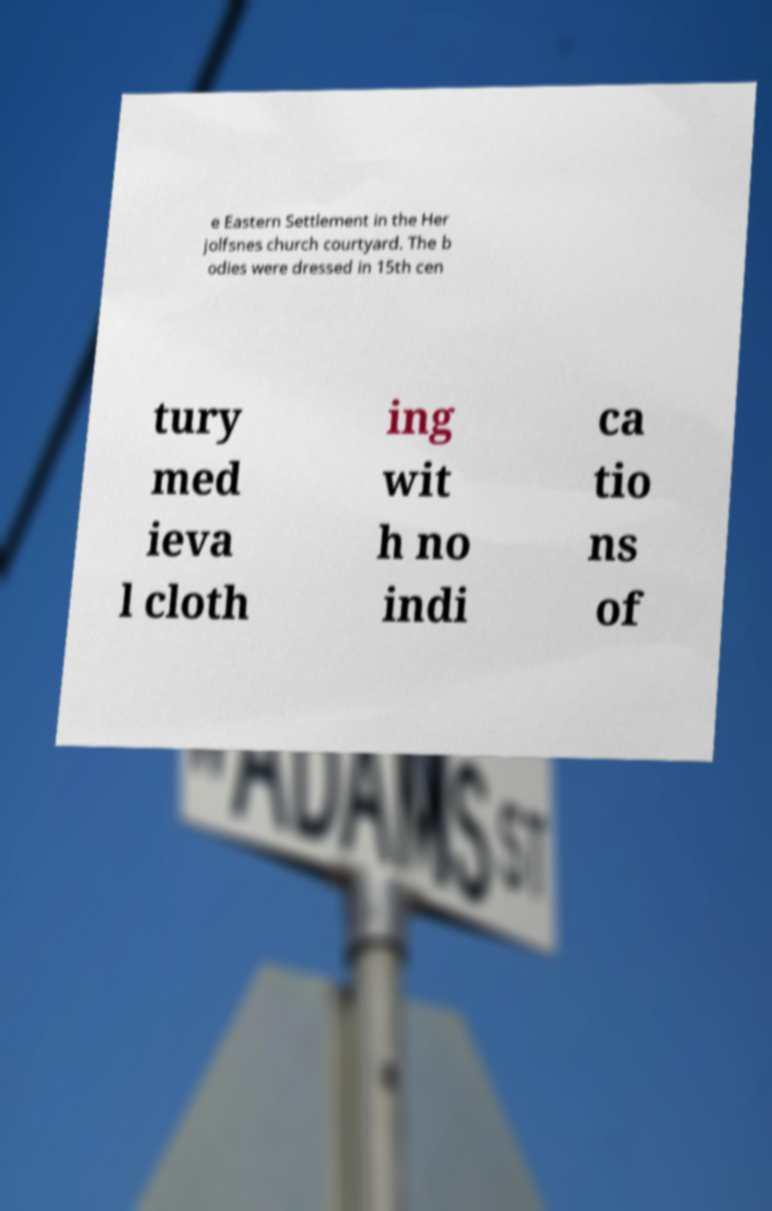Can you read and provide the text displayed in the image?This photo seems to have some interesting text. Can you extract and type it out for me? e Eastern Settlement in the Her jolfsnes church courtyard. The b odies were dressed in 15th cen tury med ieva l cloth ing wit h no indi ca tio ns of 